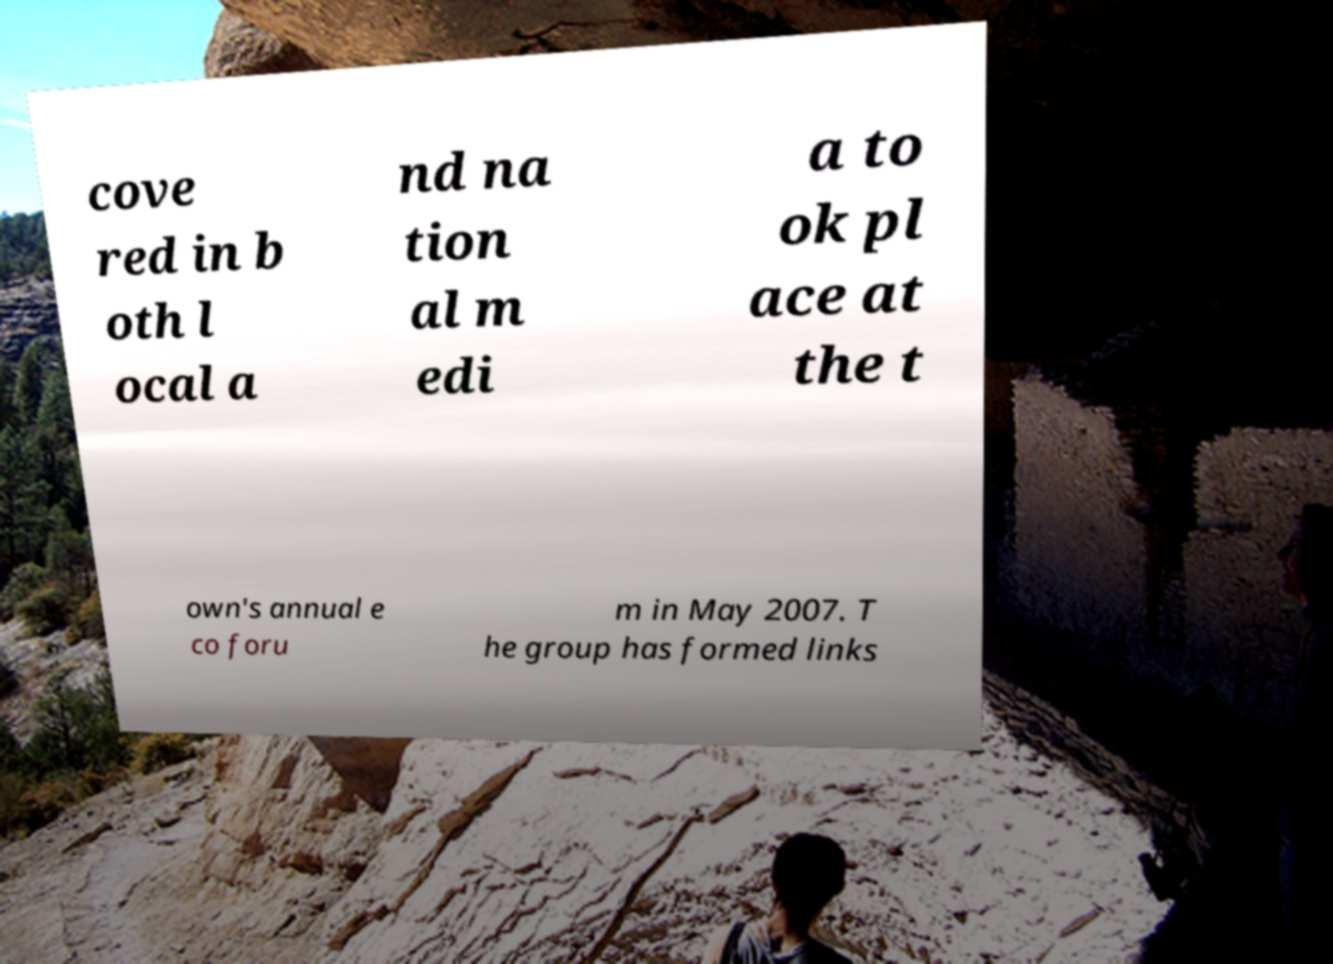Can you read and provide the text displayed in the image?This photo seems to have some interesting text. Can you extract and type it out for me? cove red in b oth l ocal a nd na tion al m edi a to ok pl ace at the t own's annual e co foru m in May 2007. T he group has formed links 